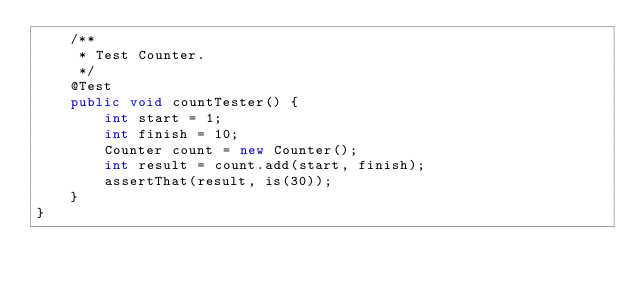Convert code to text. <code><loc_0><loc_0><loc_500><loc_500><_Java_>    /**
     * Test Counter.
     */
    @Test
    public void countTester() {
        int start = 1;
        int finish = 10;
        Counter count = new Counter();
        int result = count.add(start, finish);
        assertThat(result, is(30));
    }
}</code> 